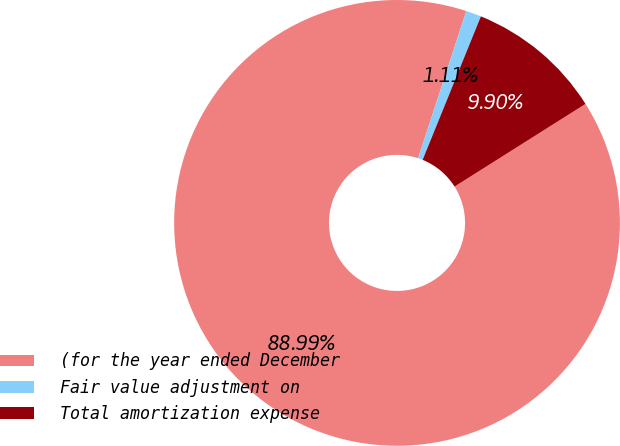Convert chart. <chart><loc_0><loc_0><loc_500><loc_500><pie_chart><fcel>(for the year ended December<fcel>Fair value adjustment on<fcel>Total amortization expense<nl><fcel>89.0%<fcel>1.11%<fcel>9.9%<nl></chart> 